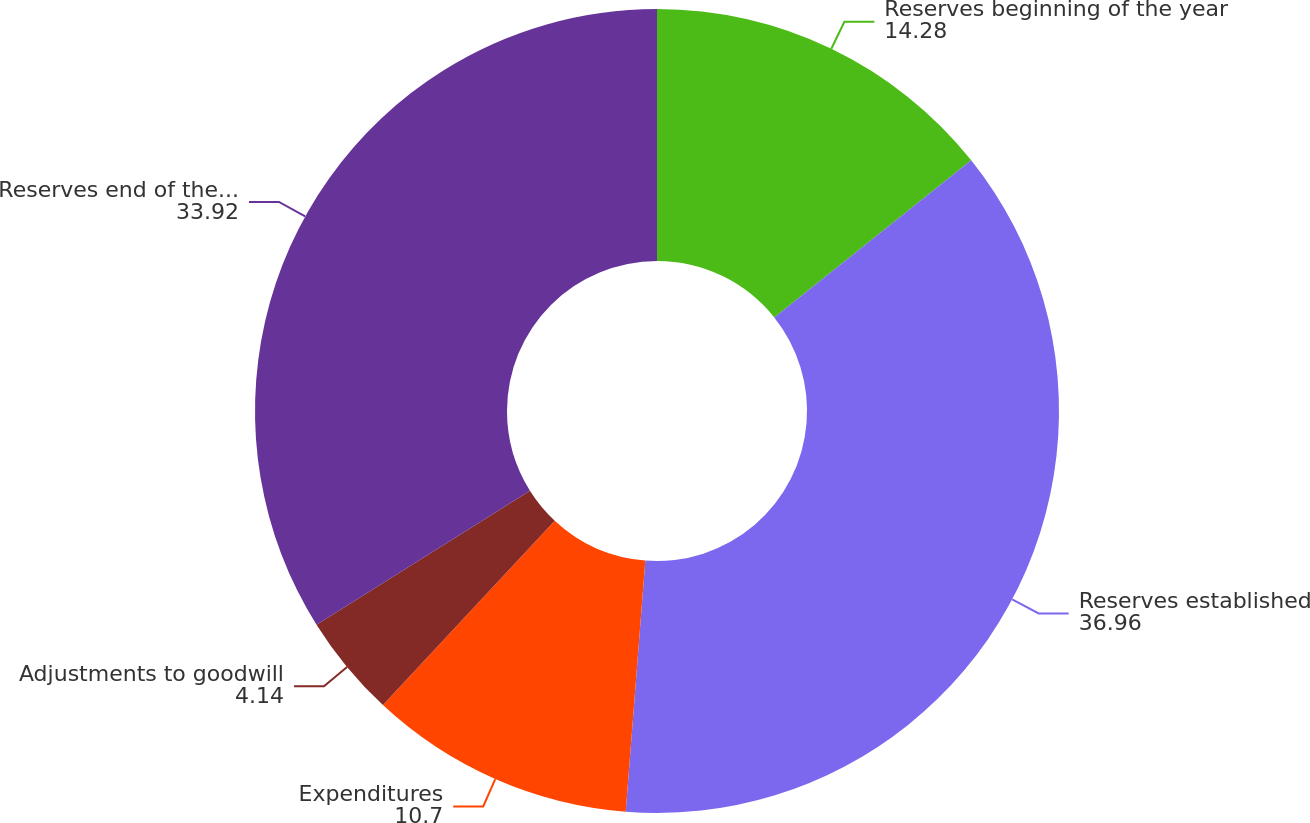Convert chart to OTSL. <chart><loc_0><loc_0><loc_500><loc_500><pie_chart><fcel>Reserves beginning of the year<fcel>Reserves established<fcel>Expenditures<fcel>Adjustments to goodwill<fcel>Reserves end of the year<nl><fcel>14.28%<fcel>36.96%<fcel>10.7%<fcel>4.14%<fcel>33.92%<nl></chart> 